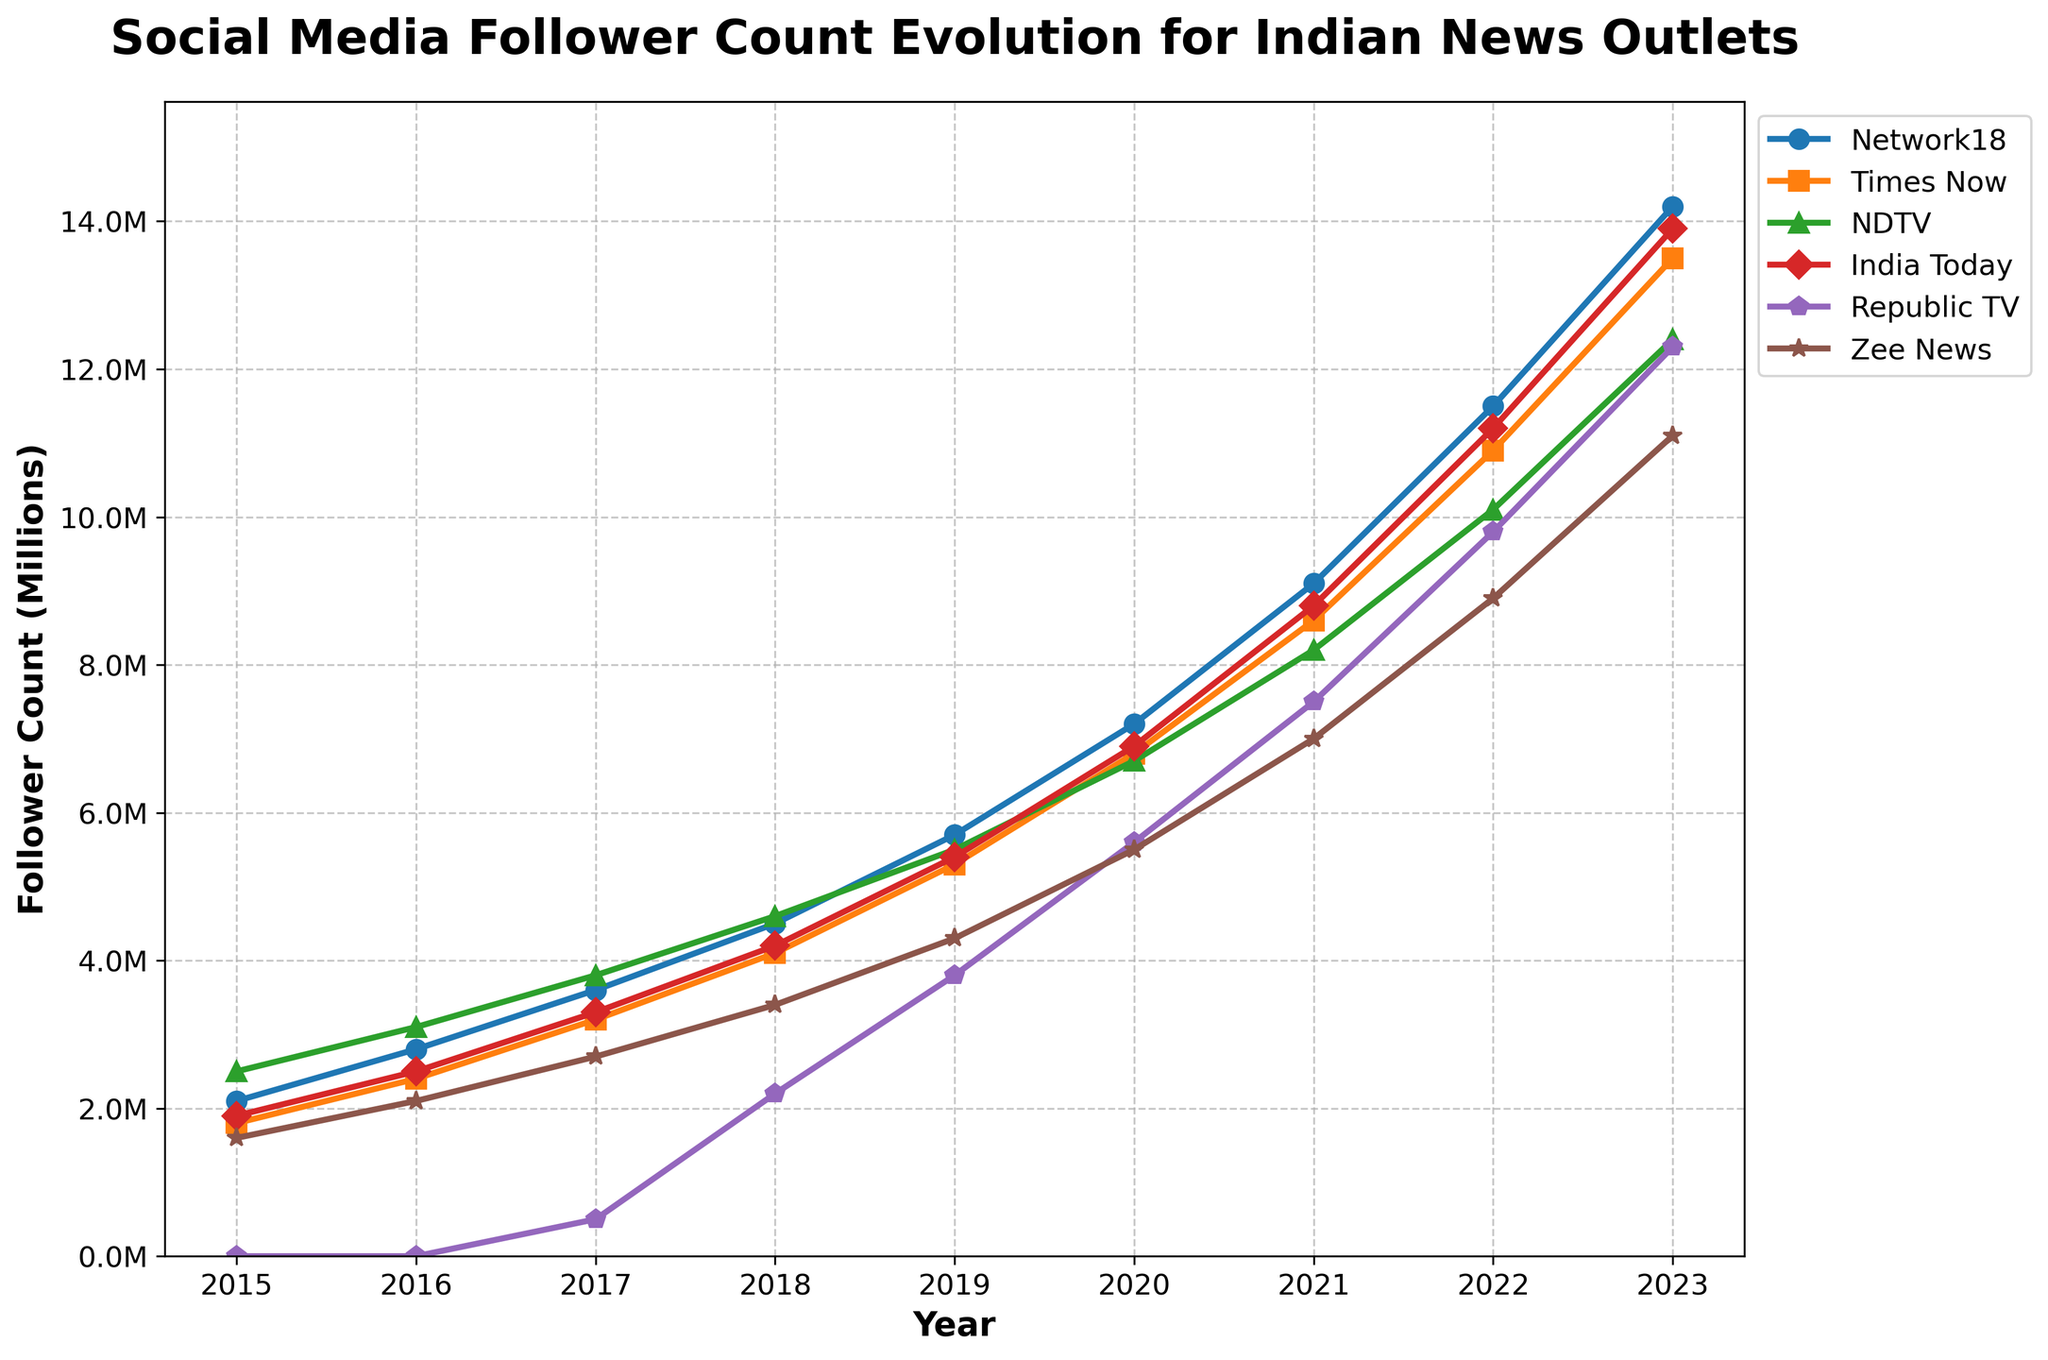What was the follower count for Republic TV in 2017? Locate the curve for Republic TV and find the point at the year 2017. The follower count can be read from the y-axis.
Answer: 500,000 Between 2015 and 2023, which news outlet had the fastest growth in social media followers? Compare the follower counts from 2015 to 2023 for each news outlet. Calculate the difference between the counts for each outlet. The outlet with the largest difference has the fastest growth.
Answer: India Today Which year did Network18 surpass 10 million followers? Locate the curve for Network18 and identify the year where the curve first crosses the 10 million mark on the y-axis.
Answer: 2022 In 2020, which news outlet had the lowest follower count? Find the values for each news outlet in 2020 and identify the smallest value. The corresponding outlet will have the lowest follower count.
Answer: Zee News How many years did it take for India Today's follower count to go from 1.9 million to 13.9 million? Find the initial year where the follower count was 1.9 million and the final year where it was 13.9 million. Subtract the initial year from the final year to get the number of years taken.
Answer: 8 years (2015 to 2023) Which year saw the largest increase in follower count for NDTV? Calculate the year-on-year differences in follower counts for NDTV. Identify the year with the largest difference.
Answer: 2016-2017 Did any news outlet have a follower count below 1 million in 2017? Check the follower counts for all outlets in 2017. Identify if any count is below 1 million.
Answer: No Between 2015 and 2023, in which years did Times Now have a higher follower count than Network18? Compare the follower counts for Times Now and Network18 year by year between 2015 and 2023. Identify the years where Times Now's count is higher.
Answer: 2015, 2016 Which news outlet had the most followers in 2023? Look at the follower counts for all news outlets in 2023 and identify the highest value.
Answer: India Today What is the average follower count of Zee News from 2015 to 2023? Sum the follower counts of Zee News from 2015 to 2023 and divide by the number of years (9).
Answer: 4,888,888 (rounded to nearest whole number) 